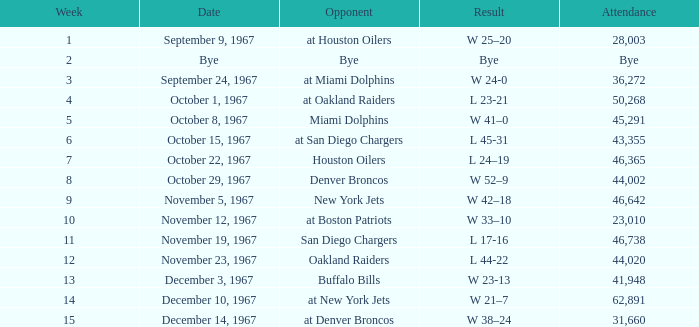In which week was the game on december 14, 1967 held? 15.0. Parse the table in full. {'header': ['Week', 'Date', 'Opponent', 'Result', 'Attendance'], 'rows': [['1', 'September 9, 1967', 'at Houston Oilers', 'W 25–20', '28,003'], ['2', 'Bye', 'Bye', 'Bye', 'Bye'], ['3', 'September 24, 1967', 'at Miami Dolphins', 'W 24-0', '36,272'], ['4', 'October 1, 1967', 'at Oakland Raiders', 'L 23-21', '50,268'], ['5', 'October 8, 1967', 'Miami Dolphins', 'W 41–0', '45,291'], ['6', 'October 15, 1967', 'at San Diego Chargers', 'L 45-31', '43,355'], ['7', 'October 22, 1967', 'Houston Oilers', 'L 24–19', '46,365'], ['8', 'October 29, 1967', 'Denver Broncos', 'W 52–9', '44,002'], ['9', 'November 5, 1967', 'New York Jets', 'W 42–18', '46,642'], ['10', 'November 12, 1967', 'at Boston Patriots', 'W 33–10', '23,010'], ['11', 'November 19, 1967', 'San Diego Chargers', 'L 17-16', '46,738'], ['12', 'November 23, 1967', 'Oakland Raiders', 'L 44-22', '44,020'], ['13', 'December 3, 1967', 'Buffalo Bills', 'W 23-13', '41,948'], ['14', 'December 10, 1967', 'at New York Jets', 'W 21–7', '62,891'], ['15', 'December 14, 1967', 'at Denver Broncos', 'W 38–24', '31,660']]} 